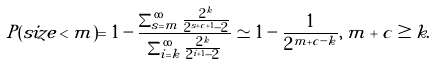Convert formula to latex. <formula><loc_0><loc_0><loc_500><loc_500>P ( s i z e < m ) = 1 - \frac { \sum _ { s = m } ^ { \infty } \frac { 2 ^ { k } } { 2 ^ { s + c + 1 } - 2 } } { \sum _ { i = k } ^ { \infty } \frac { 2 ^ { k } } { 2 ^ { i + 1 } - 2 } } \simeq 1 - \frac { 1 } { 2 ^ { m + c - k } } , \, m + c \geq k .</formula> 